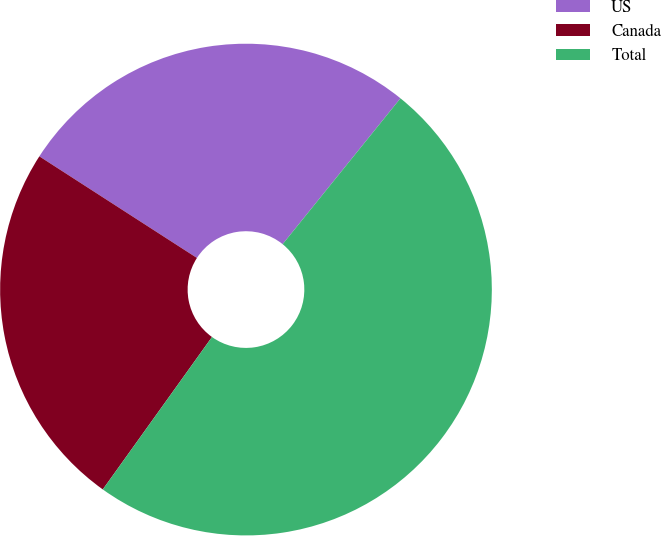<chart> <loc_0><loc_0><loc_500><loc_500><pie_chart><fcel>US<fcel>Canada<fcel>Total<nl><fcel>26.7%<fcel>24.22%<fcel>49.08%<nl></chart> 